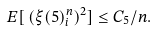Convert formula to latex. <formula><loc_0><loc_0><loc_500><loc_500>E [ \, ( \xi ( 5 ) _ { i } ^ { n } ) ^ { 2 } ] \leq C _ { 5 } / n .</formula> 